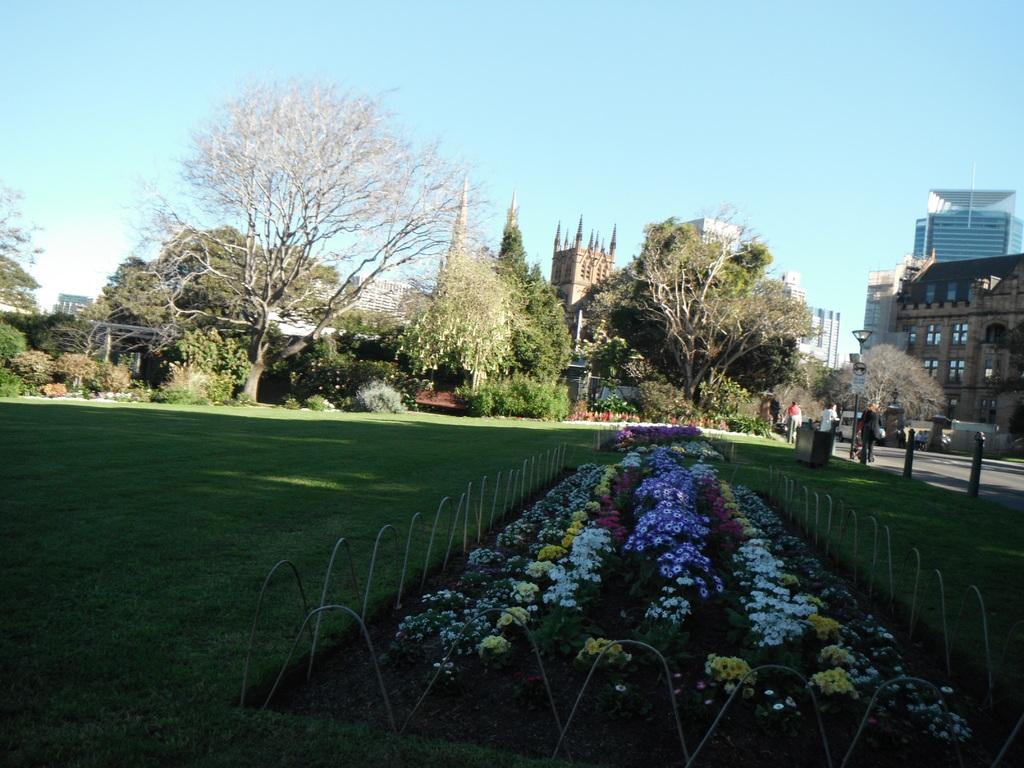In one or two sentences, can you explain what this image depicts? In this image there are few plants having flowers which are surrounded by fence. There are few poles on the grassland having few plants and trees. Few persons are walking on the road. There is a street light. Right side there are few buildings. Top of image there is sky. 